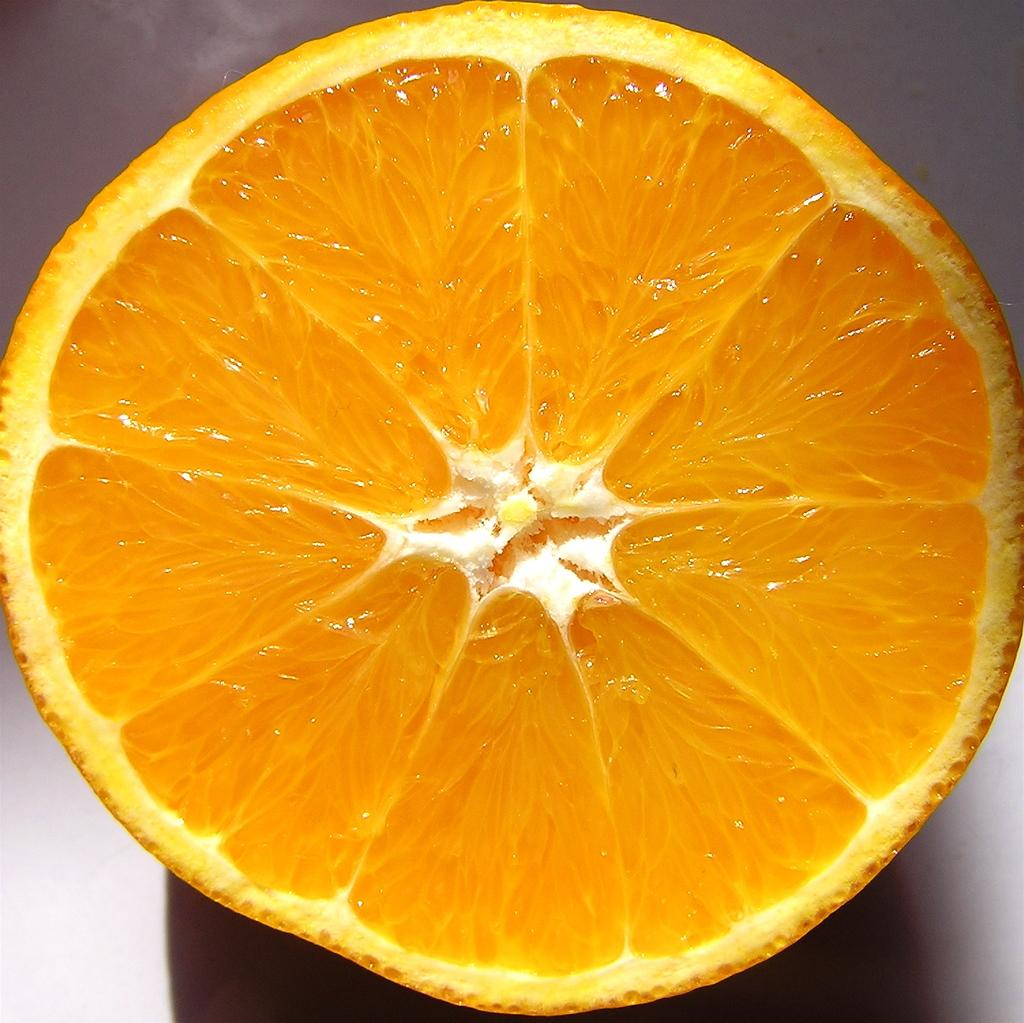What fruit is present in the image? There is an orange in the image. How is the orange depicted in the image? The orange is cut in the image. On what surface is the cut orange placed? The cut orange is placed on a white surface. What type of sound can be heard coming from the orange in the image? There is no sound coming from the orange in the image, as it is a fruit and does not produce sound. 